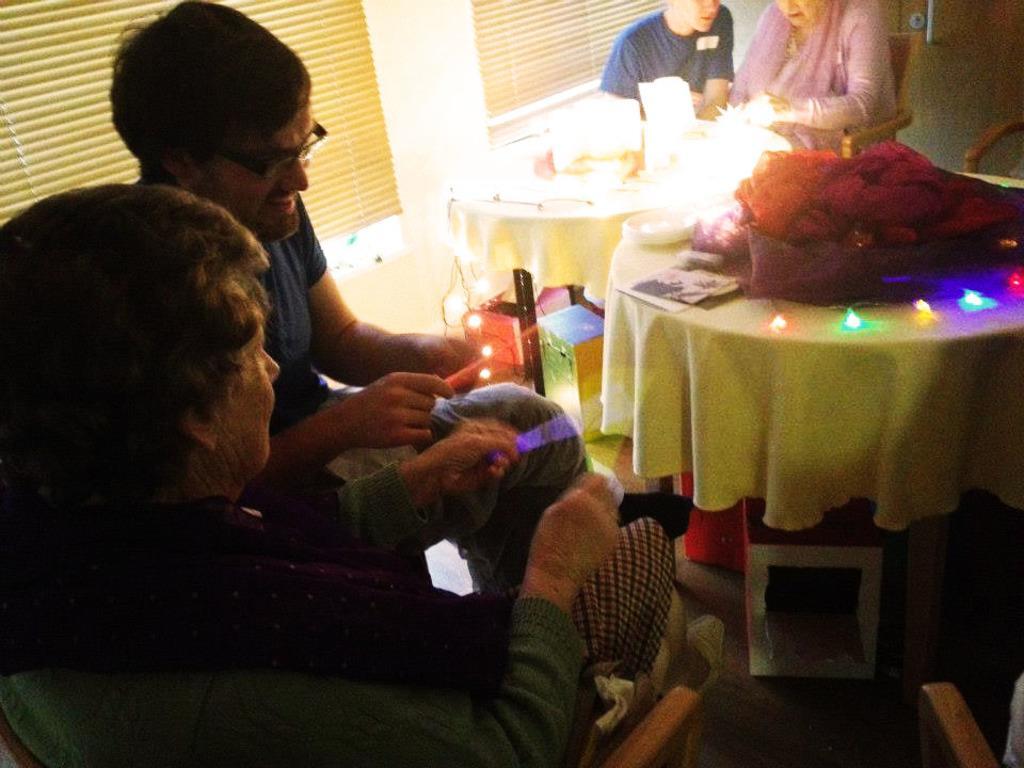Could you give a brief overview of what you see in this image? there are four persons sitting in the chair two persons on one side and two persons on other side there are two tables in which different items are present on it. 